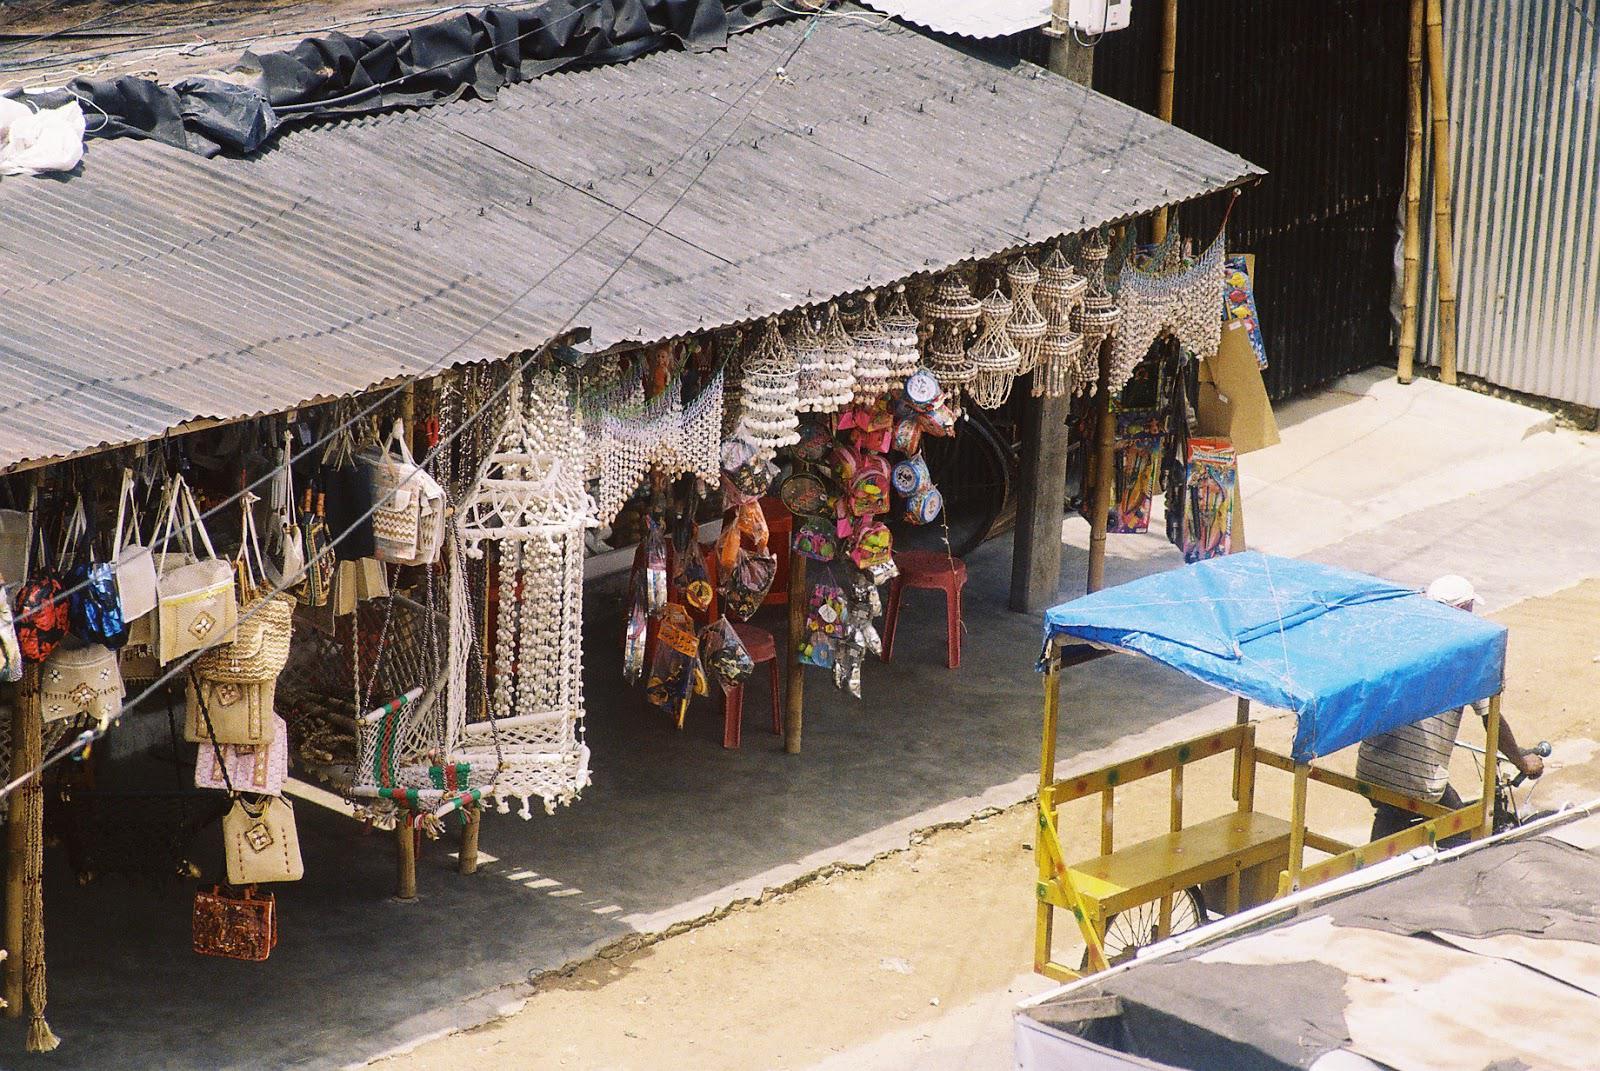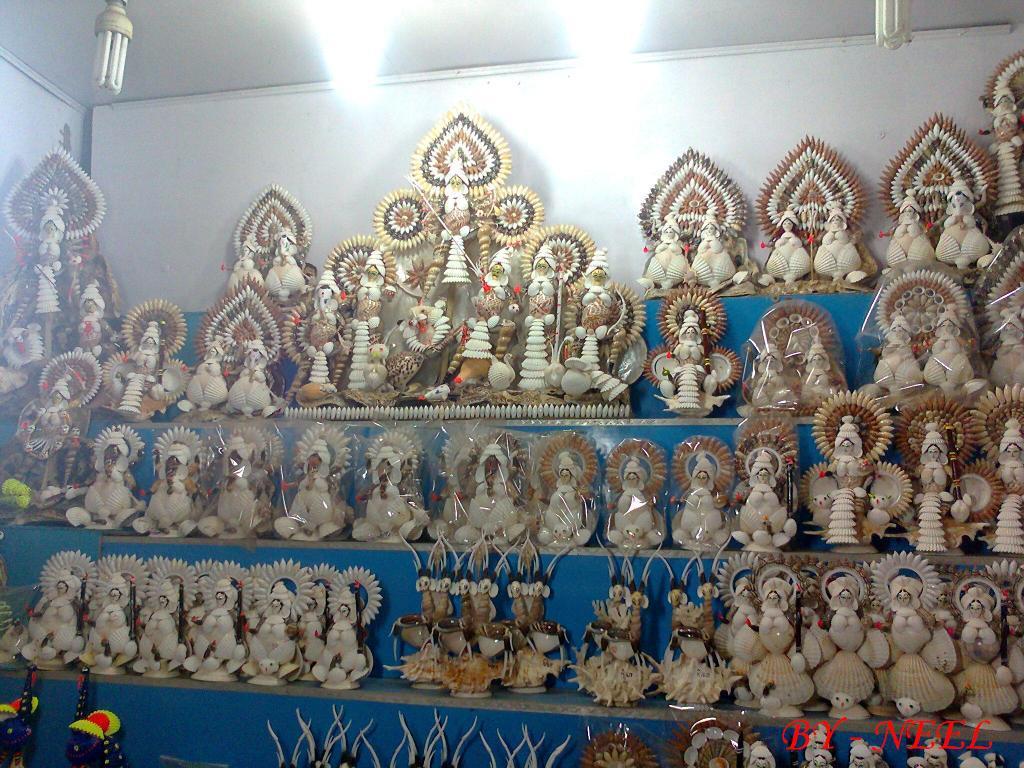The first image is the image on the left, the second image is the image on the right. Given the left and right images, does the statement "There are at least two crabs with blue and red colors on it." hold true? Answer yes or no. No. The first image is the image on the left, the second image is the image on the right. Evaluate the accuracy of this statement regarding the images: "There are at least three crabs in the image pair.". Is it true? Answer yes or no. No. 